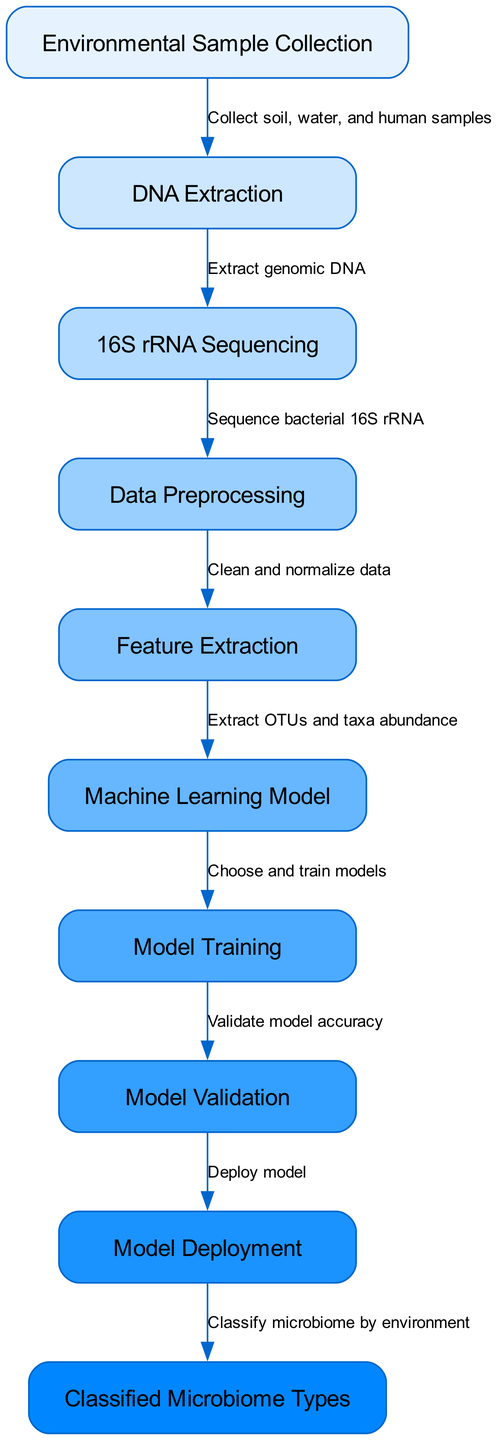What is the first step in the machine learning process? The first step, as indicated by the initial node, is "Environmental Sample Collection." This node connects to the next step, which is DNA Extraction.
Answer: Environmental Sample Collection How many nodes are in the diagram? By counting the nodes listed, there are a total of 10 nodes, each representing a step in the process.
Answer: 10 What is the label for the node that represents the process of extracting genomic DNA? The node labeled "DNA Extraction" represents the process of extracting genomic DNA and is the second node in the diagram.
Answer: DNA Extraction What connection comes after data preprocessing? The next step after "Data Preprocessing" is "Feature Extraction," which is linked as the subsequent node in the flow.
Answer: Feature Extraction Which node is linked to the "Model Validation"? "Model Validation" is directly connected to "Model Training," indicating the flow from training to validating the model.
Answer: Model Training How are the classified microbiome types ultimately determined? The classified microbiome types are determined after the "Model Deployment" node, which indicates the deployment of the trained model for classification based on environmental samples.
Answer: Classify microbiome by environment What kind of data is cleaned and normalized during the data preprocessing stage? The data that is cleaned and normalized pertains to the results obtained from "16S rRNA Sequencing," ensuring that it is ready for feature extraction.
Answer: Sequencing data What is the role of the Machine Learning Model node in this process? The "Machine Learning Model" node is where different machine learning models are selected and trained, playing a crucial role in the classification process.
Answer: Choose and train models Which step involves validating the model's accuracy? The step that involves validating the model's accuracy is labeled as "Model Validation," showing the importance of ensuring the model performs well.
Answer: Model Validation 